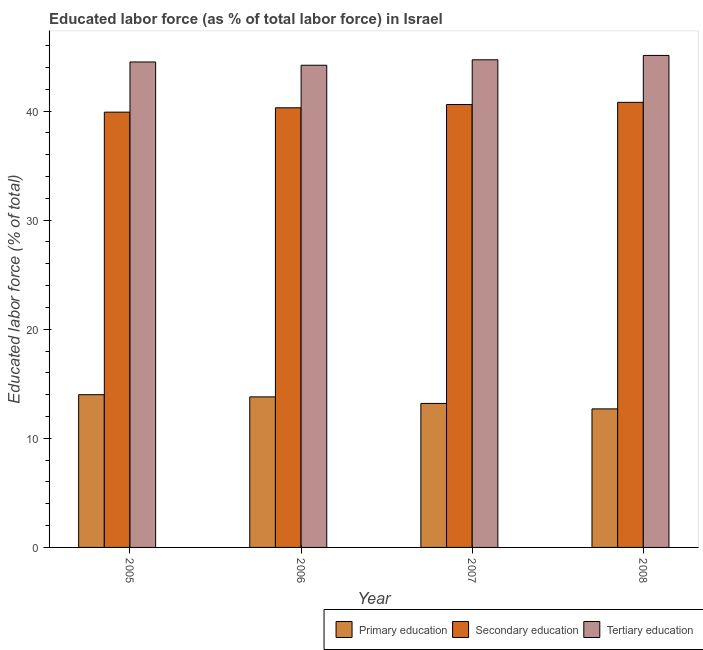How many different coloured bars are there?
Make the answer very short. 3. How many groups of bars are there?
Provide a succinct answer. 4. What is the label of the 2nd group of bars from the left?
Provide a succinct answer. 2006. What is the percentage of labor force who received primary education in 2006?
Ensure brevity in your answer.  13.8. Across all years, what is the maximum percentage of labor force who received secondary education?
Provide a short and direct response. 40.8. Across all years, what is the minimum percentage of labor force who received primary education?
Offer a very short reply. 12.7. In which year was the percentage of labor force who received primary education minimum?
Your answer should be very brief. 2008. What is the total percentage of labor force who received primary education in the graph?
Ensure brevity in your answer.  53.7. What is the difference between the percentage of labor force who received tertiary education in 2007 and that in 2008?
Keep it short and to the point. -0.4. What is the difference between the percentage of labor force who received tertiary education in 2006 and the percentage of labor force who received primary education in 2005?
Your answer should be compact. -0.3. What is the average percentage of labor force who received tertiary education per year?
Provide a short and direct response. 44.63. In how many years, is the percentage of labor force who received primary education greater than 6 %?
Give a very brief answer. 4. What is the ratio of the percentage of labor force who received tertiary education in 2005 to that in 2007?
Your response must be concise. 1. Is the percentage of labor force who received primary education in 2006 less than that in 2007?
Provide a succinct answer. No. What is the difference between the highest and the second highest percentage of labor force who received tertiary education?
Ensure brevity in your answer.  0.4. What is the difference between the highest and the lowest percentage of labor force who received primary education?
Offer a terse response. 1.3. In how many years, is the percentage of labor force who received primary education greater than the average percentage of labor force who received primary education taken over all years?
Provide a short and direct response. 2. What does the 3rd bar from the left in 2005 represents?
Your answer should be very brief. Tertiary education. What does the 3rd bar from the right in 2006 represents?
Make the answer very short. Primary education. What is the difference between two consecutive major ticks on the Y-axis?
Your answer should be very brief. 10. Where does the legend appear in the graph?
Your response must be concise. Bottom right. What is the title of the graph?
Your answer should be very brief. Educated labor force (as % of total labor force) in Israel. What is the label or title of the Y-axis?
Your response must be concise. Educated labor force (% of total). What is the Educated labor force (% of total) of Primary education in 2005?
Your response must be concise. 14. What is the Educated labor force (% of total) in Secondary education in 2005?
Make the answer very short. 39.9. What is the Educated labor force (% of total) in Tertiary education in 2005?
Make the answer very short. 44.5. What is the Educated labor force (% of total) of Primary education in 2006?
Ensure brevity in your answer.  13.8. What is the Educated labor force (% of total) of Secondary education in 2006?
Make the answer very short. 40.3. What is the Educated labor force (% of total) of Tertiary education in 2006?
Provide a short and direct response. 44.2. What is the Educated labor force (% of total) in Primary education in 2007?
Make the answer very short. 13.2. What is the Educated labor force (% of total) of Secondary education in 2007?
Your answer should be very brief. 40.6. What is the Educated labor force (% of total) of Tertiary education in 2007?
Your answer should be compact. 44.7. What is the Educated labor force (% of total) in Primary education in 2008?
Keep it short and to the point. 12.7. What is the Educated labor force (% of total) in Secondary education in 2008?
Provide a short and direct response. 40.8. What is the Educated labor force (% of total) in Tertiary education in 2008?
Your response must be concise. 45.1. Across all years, what is the maximum Educated labor force (% of total) in Primary education?
Keep it short and to the point. 14. Across all years, what is the maximum Educated labor force (% of total) of Secondary education?
Offer a very short reply. 40.8. Across all years, what is the maximum Educated labor force (% of total) in Tertiary education?
Make the answer very short. 45.1. Across all years, what is the minimum Educated labor force (% of total) in Primary education?
Keep it short and to the point. 12.7. Across all years, what is the minimum Educated labor force (% of total) of Secondary education?
Offer a terse response. 39.9. Across all years, what is the minimum Educated labor force (% of total) in Tertiary education?
Give a very brief answer. 44.2. What is the total Educated labor force (% of total) of Primary education in the graph?
Offer a very short reply. 53.7. What is the total Educated labor force (% of total) of Secondary education in the graph?
Your answer should be compact. 161.6. What is the total Educated labor force (% of total) of Tertiary education in the graph?
Offer a terse response. 178.5. What is the difference between the Educated labor force (% of total) of Primary education in 2005 and that in 2006?
Your answer should be very brief. 0.2. What is the difference between the Educated labor force (% of total) in Secondary education in 2005 and that in 2006?
Your answer should be compact. -0.4. What is the difference between the Educated labor force (% of total) in Tertiary education in 2005 and that in 2006?
Ensure brevity in your answer.  0.3. What is the difference between the Educated labor force (% of total) in Primary education in 2005 and that in 2008?
Offer a very short reply. 1.3. What is the difference between the Educated labor force (% of total) of Secondary education in 2005 and that in 2008?
Offer a very short reply. -0.9. What is the difference between the Educated labor force (% of total) of Tertiary education in 2005 and that in 2008?
Your answer should be very brief. -0.6. What is the difference between the Educated labor force (% of total) in Primary education in 2006 and that in 2008?
Your response must be concise. 1.1. What is the difference between the Educated labor force (% of total) in Tertiary education in 2006 and that in 2008?
Provide a short and direct response. -0.9. What is the difference between the Educated labor force (% of total) of Primary education in 2007 and that in 2008?
Provide a short and direct response. 0.5. What is the difference between the Educated labor force (% of total) in Tertiary education in 2007 and that in 2008?
Keep it short and to the point. -0.4. What is the difference between the Educated labor force (% of total) in Primary education in 2005 and the Educated labor force (% of total) in Secondary education in 2006?
Make the answer very short. -26.3. What is the difference between the Educated labor force (% of total) in Primary education in 2005 and the Educated labor force (% of total) in Tertiary education in 2006?
Your response must be concise. -30.2. What is the difference between the Educated labor force (% of total) in Primary education in 2005 and the Educated labor force (% of total) in Secondary education in 2007?
Keep it short and to the point. -26.6. What is the difference between the Educated labor force (% of total) of Primary education in 2005 and the Educated labor force (% of total) of Tertiary education in 2007?
Your response must be concise. -30.7. What is the difference between the Educated labor force (% of total) in Primary education in 2005 and the Educated labor force (% of total) in Secondary education in 2008?
Offer a terse response. -26.8. What is the difference between the Educated labor force (% of total) of Primary education in 2005 and the Educated labor force (% of total) of Tertiary education in 2008?
Give a very brief answer. -31.1. What is the difference between the Educated labor force (% of total) of Primary education in 2006 and the Educated labor force (% of total) of Secondary education in 2007?
Your answer should be compact. -26.8. What is the difference between the Educated labor force (% of total) of Primary education in 2006 and the Educated labor force (% of total) of Tertiary education in 2007?
Your answer should be compact. -30.9. What is the difference between the Educated labor force (% of total) in Primary education in 2006 and the Educated labor force (% of total) in Tertiary education in 2008?
Keep it short and to the point. -31.3. What is the difference between the Educated labor force (% of total) of Secondary education in 2006 and the Educated labor force (% of total) of Tertiary education in 2008?
Your answer should be very brief. -4.8. What is the difference between the Educated labor force (% of total) of Primary education in 2007 and the Educated labor force (% of total) of Secondary education in 2008?
Your response must be concise. -27.6. What is the difference between the Educated labor force (% of total) in Primary education in 2007 and the Educated labor force (% of total) in Tertiary education in 2008?
Offer a terse response. -31.9. What is the average Educated labor force (% of total) of Primary education per year?
Offer a very short reply. 13.43. What is the average Educated labor force (% of total) of Secondary education per year?
Offer a very short reply. 40.4. What is the average Educated labor force (% of total) of Tertiary education per year?
Your answer should be very brief. 44.62. In the year 2005, what is the difference between the Educated labor force (% of total) of Primary education and Educated labor force (% of total) of Secondary education?
Offer a terse response. -25.9. In the year 2005, what is the difference between the Educated labor force (% of total) in Primary education and Educated labor force (% of total) in Tertiary education?
Keep it short and to the point. -30.5. In the year 2006, what is the difference between the Educated labor force (% of total) in Primary education and Educated labor force (% of total) in Secondary education?
Offer a terse response. -26.5. In the year 2006, what is the difference between the Educated labor force (% of total) in Primary education and Educated labor force (% of total) in Tertiary education?
Keep it short and to the point. -30.4. In the year 2007, what is the difference between the Educated labor force (% of total) of Primary education and Educated labor force (% of total) of Secondary education?
Offer a terse response. -27.4. In the year 2007, what is the difference between the Educated labor force (% of total) of Primary education and Educated labor force (% of total) of Tertiary education?
Make the answer very short. -31.5. In the year 2008, what is the difference between the Educated labor force (% of total) in Primary education and Educated labor force (% of total) in Secondary education?
Offer a terse response. -28.1. In the year 2008, what is the difference between the Educated labor force (% of total) of Primary education and Educated labor force (% of total) of Tertiary education?
Provide a short and direct response. -32.4. What is the ratio of the Educated labor force (% of total) of Primary education in 2005 to that in 2006?
Keep it short and to the point. 1.01. What is the ratio of the Educated labor force (% of total) in Tertiary education in 2005 to that in 2006?
Keep it short and to the point. 1.01. What is the ratio of the Educated labor force (% of total) in Primary education in 2005 to that in 2007?
Provide a succinct answer. 1.06. What is the ratio of the Educated labor force (% of total) of Secondary education in 2005 to that in 2007?
Provide a short and direct response. 0.98. What is the ratio of the Educated labor force (% of total) of Primary education in 2005 to that in 2008?
Provide a short and direct response. 1.1. What is the ratio of the Educated labor force (% of total) in Secondary education in 2005 to that in 2008?
Your answer should be compact. 0.98. What is the ratio of the Educated labor force (% of total) in Tertiary education in 2005 to that in 2008?
Your answer should be very brief. 0.99. What is the ratio of the Educated labor force (% of total) in Primary education in 2006 to that in 2007?
Ensure brevity in your answer.  1.05. What is the ratio of the Educated labor force (% of total) in Secondary education in 2006 to that in 2007?
Ensure brevity in your answer.  0.99. What is the ratio of the Educated labor force (% of total) in Tertiary education in 2006 to that in 2007?
Your answer should be very brief. 0.99. What is the ratio of the Educated labor force (% of total) in Primary education in 2006 to that in 2008?
Ensure brevity in your answer.  1.09. What is the ratio of the Educated labor force (% of total) in Tertiary education in 2006 to that in 2008?
Give a very brief answer. 0.98. What is the ratio of the Educated labor force (% of total) in Primary education in 2007 to that in 2008?
Your response must be concise. 1.04. What is the ratio of the Educated labor force (% of total) of Tertiary education in 2007 to that in 2008?
Provide a succinct answer. 0.99. What is the difference between the highest and the second highest Educated labor force (% of total) of Primary education?
Your answer should be very brief. 0.2. What is the difference between the highest and the second highest Educated labor force (% of total) of Tertiary education?
Your response must be concise. 0.4. What is the difference between the highest and the lowest Educated labor force (% of total) in Primary education?
Offer a terse response. 1.3. 